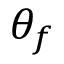Convert formula to latex. <formula><loc_0><loc_0><loc_500><loc_500>\theta _ { f }</formula> 